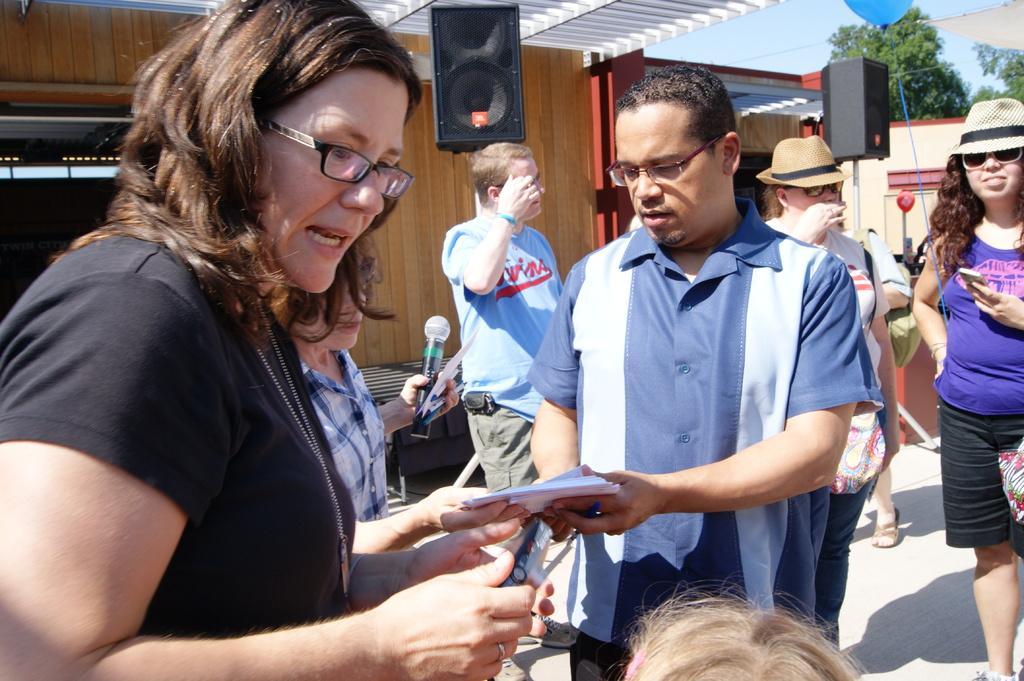In one or two sentences, can you explain what this image depicts? In this image we can see a group of persons and among them few persons are holding objects. Behind the persons we can see a wall and speakers. In the top right, we can see the sky, trees, a balloon and a roof. 